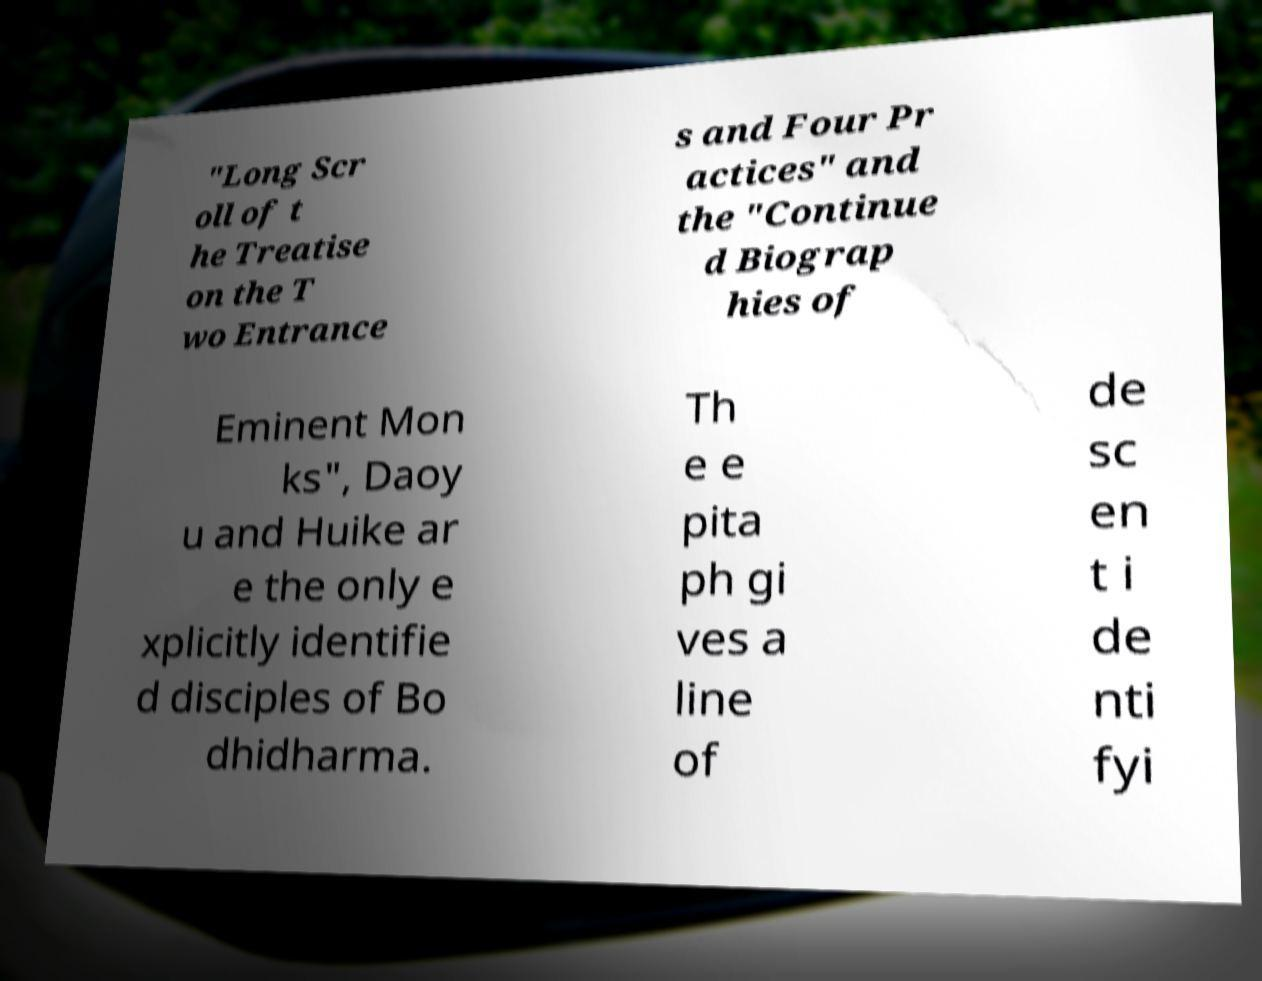Could you extract and type out the text from this image? "Long Scr oll of t he Treatise on the T wo Entrance s and Four Pr actices" and the "Continue d Biograp hies of Eminent Mon ks", Daoy u and Huike ar e the only e xplicitly identifie d disciples of Bo dhidharma. Th e e pita ph gi ves a line of de sc en t i de nti fyi 